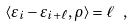<formula> <loc_0><loc_0><loc_500><loc_500>\langle \varepsilon _ { i } - \varepsilon _ { i + \ell } , \rho \rangle = \ell \ ,</formula> 